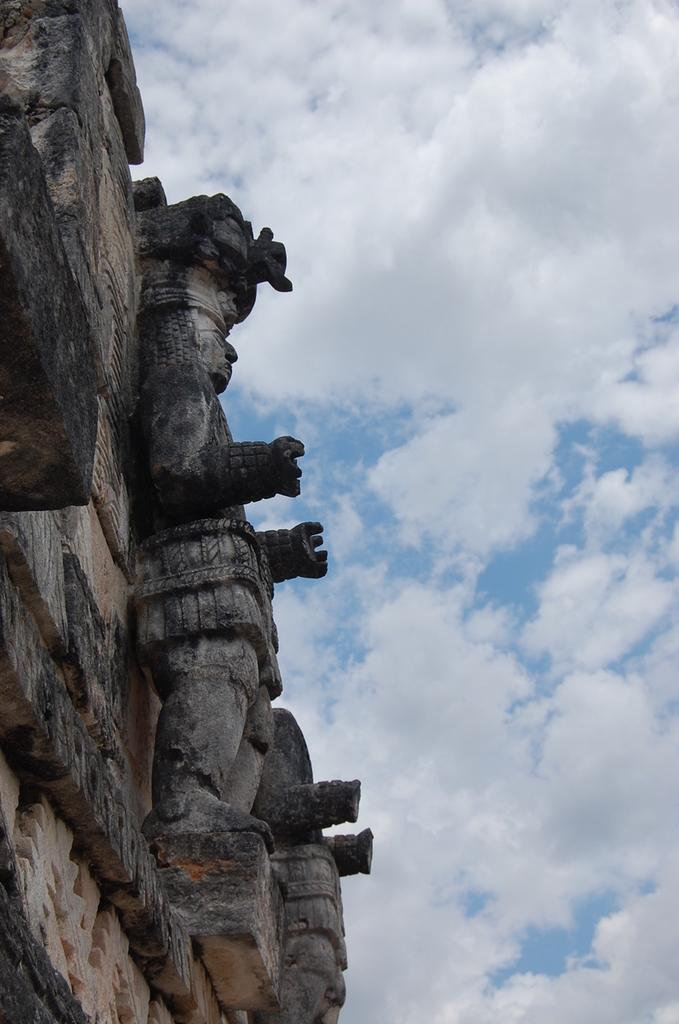What type of artifact is depicted in the image? There is an ancient sculpture in the image. Where was the sculpture discovered? The sculpture is from an archaeological site. What can be seen in the sky in the image? There are clouds visible in the sky. What type of rhythm can be heard coming from the sculpture in the image? There is no sound or rhythm associated with the sculpture in the image, as it is a static artifact. 